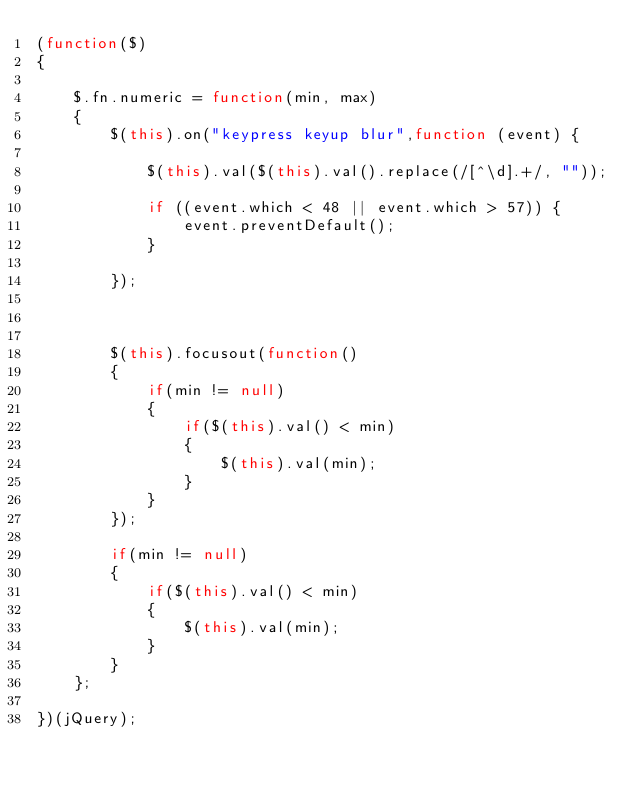Convert code to text. <code><loc_0><loc_0><loc_500><loc_500><_JavaScript_>(function($)
{

	$.fn.numeric = function(min, max)
	{
		$(this).on("keypress keyup blur",function (event) {

        	$(this).val($(this).val().replace(/[^\d].+/, ""));

	        if ((event.which < 48 || event.which > 57)) {
	            event.preventDefault();
	        }

    	});



		$(this).focusout(function()
		{
			if(min != null)
	    	{
	    		if($(this).val() < min)
	    		{
	    			$(this).val(min);
	    		}		
	    	}
		});

		if(min != null)
	    {
	    	if($(this).val() < min)
	    	{
	    		$(this).val(min);
	    	}		
	    }
	};

})(jQuery);</code> 